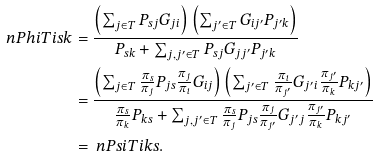Convert formula to latex. <formula><loc_0><loc_0><loc_500><loc_500>\ n P h i T { i } { s } { k } & = \frac { \left ( \sum _ { j \in T } P _ { s j } G _ { j i } \right ) \left ( \sum _ { j ^ { \prime } \in T } G _ { i j ^ { \prime } } P _ { j ^ { \prime } k } \right ) } { P _ { s k } + \sum _ { j , j ^ { \prime } \in T } P _ { s j } G _ { j j ^ { \prime } } P _ { j ^ { \prime } k } } \\ & = \frac { \left ( \sum _ { j \in T } \frac { \pi _ { s } } { \pi _ { j } } P _ { j s } \frac { \pi _ { j } } { \pi _ { i } } G _ { i j } \right ) \left ( \sum _ { j ^ { \prime } \in T } \frac { \pi _ { i } } { \pi _ { j ^ { \prime } } } G _ { j ^ { \prime } i } \frac { \pi _ { j ^ { \prime } } } { \pi _ { k } } P _ { k j ^ { \prime } } \right ) } { \frac { \pi _ { s } } { \pi _ { k } } P _ { k s } + \sum _ { j , j ^ { \prime } \in T } \frac { \pi _ { s } } { \pi _ { j } } P _ { j s } \frac { \pi _ { j } } { \pi _ { j ^ { \prime } } } G _ { j ^ { \prime } j } \frac { \pi _ { j ^ { \prime } } } { \pi _ { k } } P _ { k j ^ { \prime } } } \\ & = \ n P s i T { i } { k } { s } .</formula> 